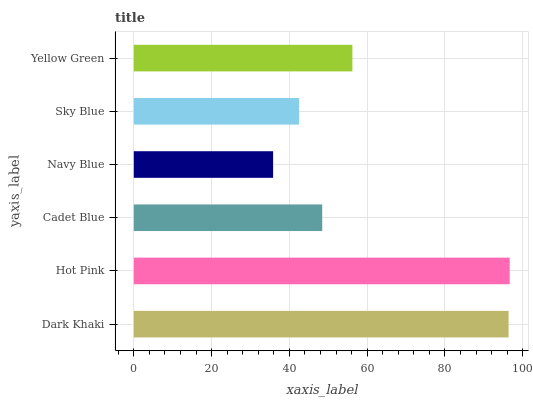Is Navy Blue the minimum?
Answer yes or no. Yes. Is Hot Pink the maximum?
Answer yes or no. Yes. Is Cadet Blue the minimum?
Answer yes or no. No. Is Cadet Blue the maximum?
Answer yes or no. No. Is Hot Pink greater than Cadet Blue?
Answer yes or no. Yes. Is Cadet Blue less than Hot Pink?
Answer yes or no. Yes. Is Cadet Blue greater than Hot Pink?
Answer yes or no. No. Is Hot Pink less than Cadet Blue?
Answer yes or no. No. Is Yellow Green the high median?
Answer yes or no. Yes. Is Cadet Blue the low median?
Answer yes or no. Yes. Is Hot Pink the high median?
Answer yes or no. No. Is Dark Khaki the low median?
Answer yes or no. No. 